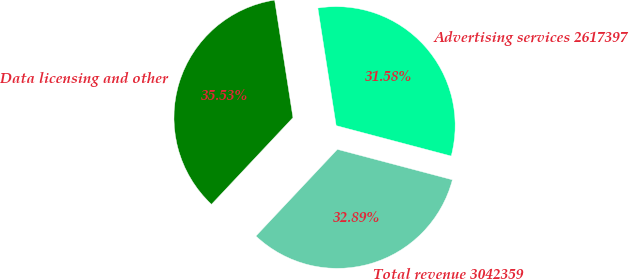<chart> <loc_0><loc_0><loc_500><loc_500><pie_chart><fcel>Advertising services 2617397<fcel>Data licensing and other<fcel>Total revenue 3042359<nl><fcel>31.58%<fcel>35.53%<fcel>32.89%<nl></chart> 